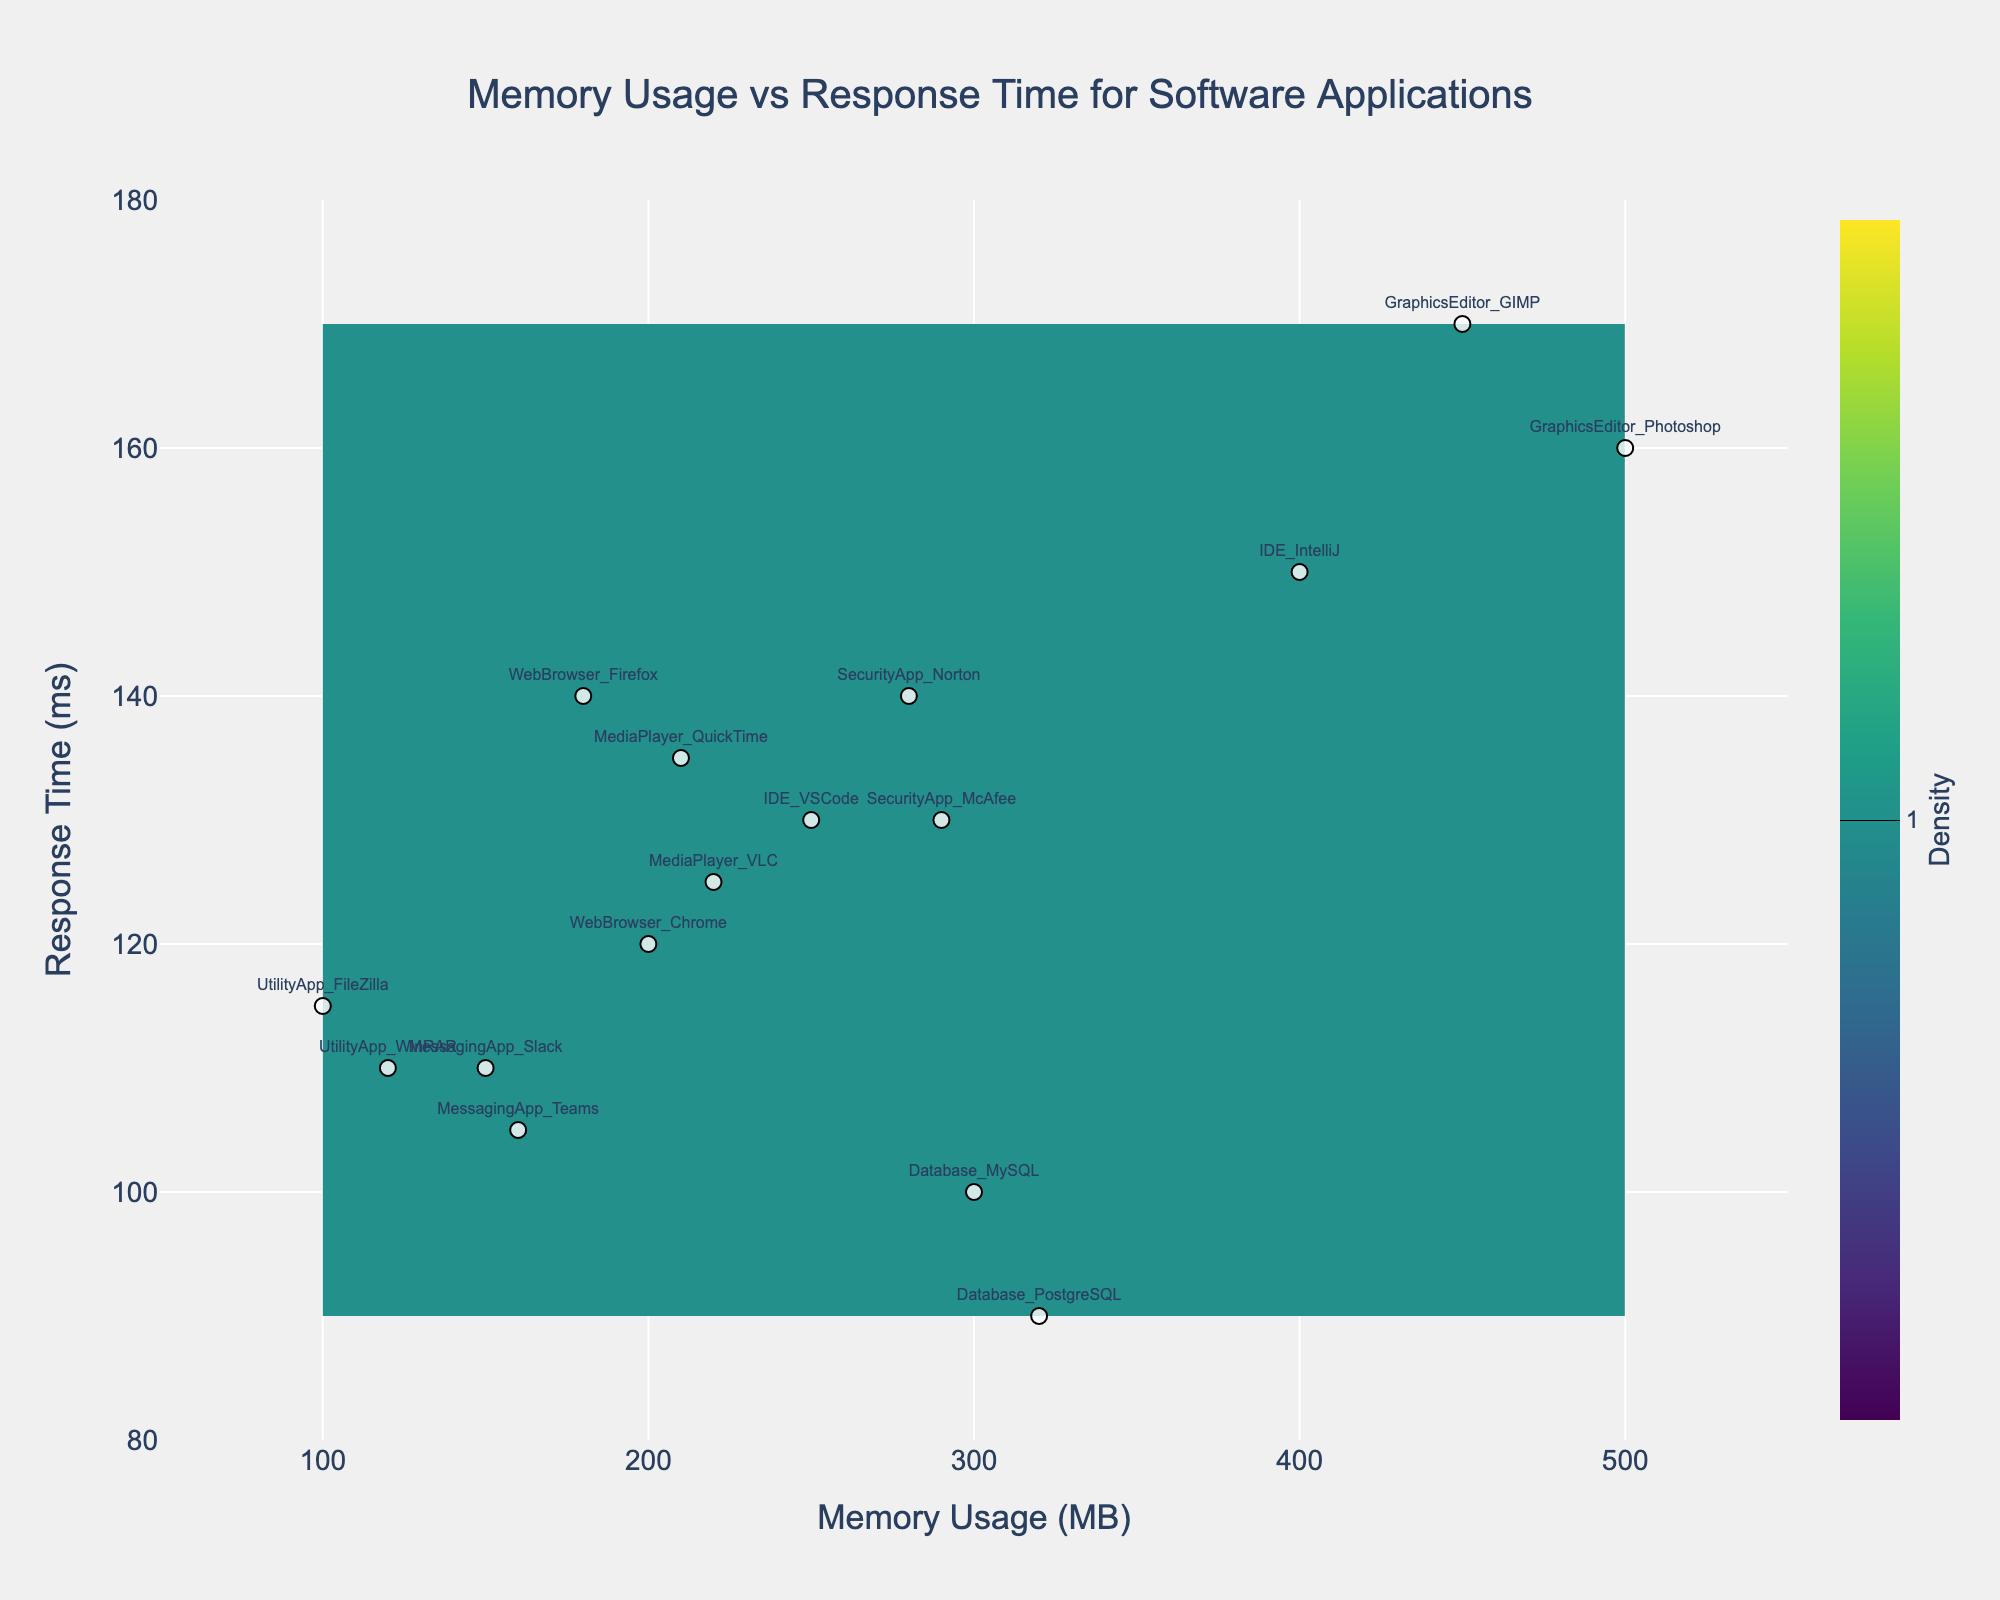What is the title of the figure? The title of the figure is displayed at the top and reads 'Memory Usage vs Response Time for Software Applications'.
Answer: Memory Usage vs Response Time for Software Applications What is the response time of the application with the highest memory usage? The highest memory usage is for 'GraphicsEditor_Photoshop' with 500 MB memory usage. The corresponding response time is 160 ms.
Answer: 160 ms How many software applications are shown in the figure? Each application is marked with a text label, and by counting these labels, we see there are 16 applications.
Answer: 16 What is the memory usage range shown on the x-axis? The x-axis displays 'Memory Usage (MB)' and ranges from 50 MB to 550 MB.
Answer: 50 MB to 550 MB Which application has the lowest response time? The lowest response time corresponds to 'Database_PostgreSQL', which has a memory usage of 320 MB and a response time of 90 ms.
Answer: Database_PostgreSQL What is the difference in response time between the applications with the highest and lowest memory usage? The highest memory usage is 500 MB ('GraphicsEditor_Photoshop') with a response time of 160 ms, and the lowest memory usage is 100 MB ('UtilityApp_FileZilla') with a response time of 115 ms. The difference is 160 - 115 = 45 ms.
Answer: 45 ms Compare the memory usage of 'MessagingApp_Teams' and 'IDE_VSCode'. Which one uses more memory and by how much? 'MessagingApp_Teams' uses 160 MB, while 'IDE_VSCode' uses 250 MB. 'IDE_VSCode' uses more memory by 250 - 160 = 90 MB.
Answer: 90 MB What is the average response time for all applications in the figure? The response times are (120, 140, 100, 90, 150, 130, 160, 170, 110, 105, 125, 135, 140, 130, 115, 110). Summing these values gives a total of 2020 ms for 16 applications. The average is 2020 / 16 = 126.25 ms.
Answer: 126.25 ms Which category of applications (e.g., "Database", "Web Browser", etc.) tend to have higher memory usage? By looking at the labels and memory usage values, "GraphicsEditor" applications ('Photoshop', 'GIMP') tend to have higher memory usage, with values of 500 MB and 450 MB respectively.
Answer: GraphicsEditor 